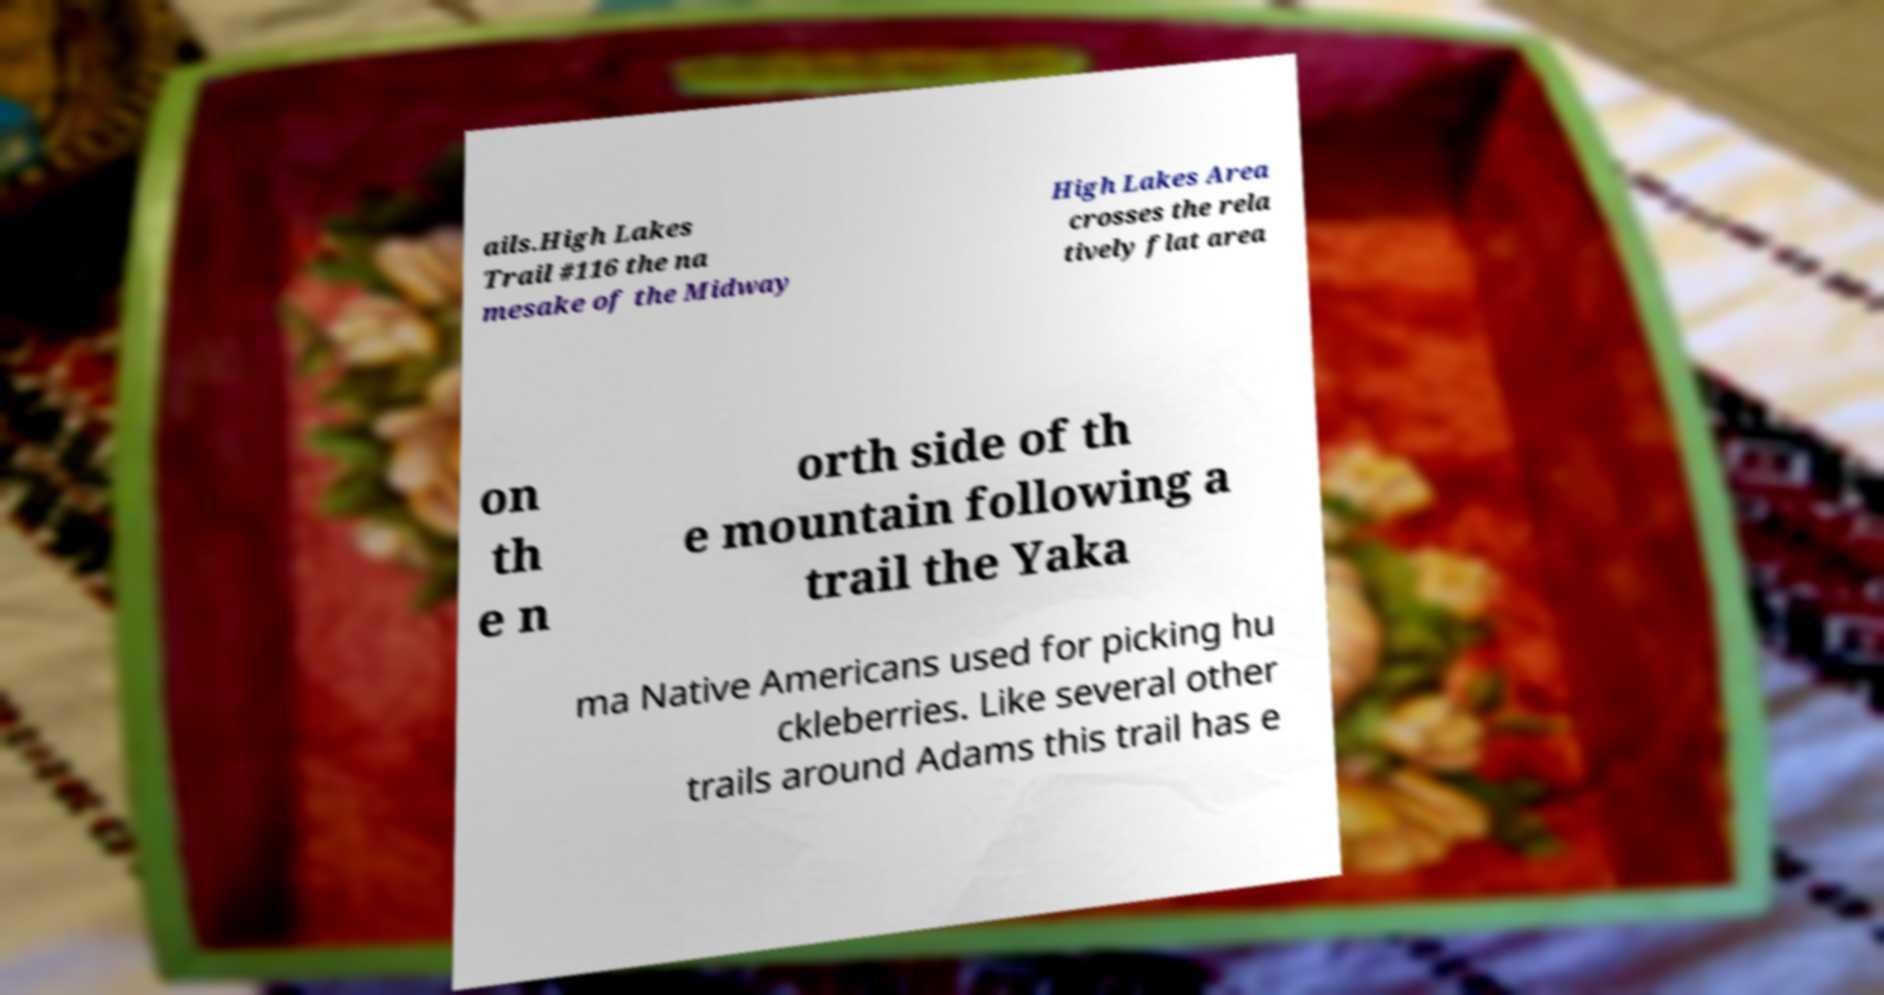Please identify and transcribe the text found in this image. ails.High Lakes Trail #116 the na mesake of the Midway High Lakes Area crosses the rela tively flat area on th e n orth side of th e mountain following a trail the Yaka ma Native Americans used for picking hu ckleberries. Like several other trails around Adams this trail has e 